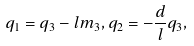Convert formula to latex. <formula><loc_0><loc_0><loc_500><loc_500>q _ { 1 } = q _ { 3 } - l m _ { 3 } , q _ { 2 } = - \frac { d } { l } q _ { 3 } ,</formula> 